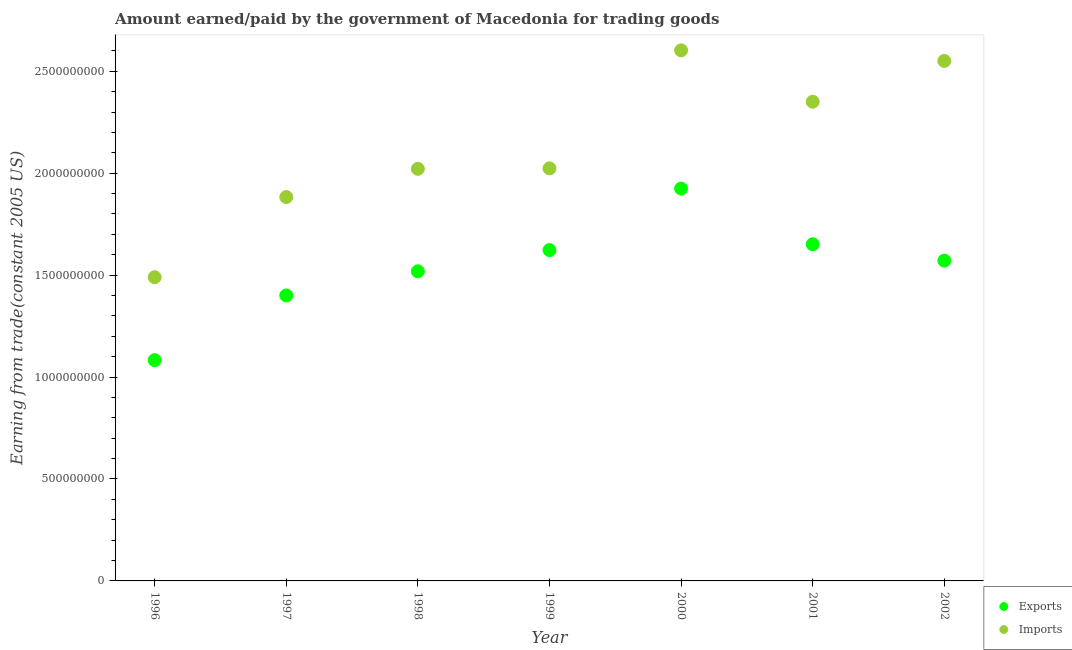How many different coloured dotlines are there?
Offer a very short reply. 2. What is the amount paid for imports in 2001?
Provide a succinct answer. 2.35e+09. Across all years, what is the maximum amount paid for imports?
Your response must be concise. 2.60e+09. Across all years, what is the minimum amount earned from exports?
Your answer should be very brief. 1.08e+09. In which year was the amount paid for imports minimum?
Give a very brief answer. 1996. What is the total amount earned from exports in the graph?
Give a very brief answer. 1.08e+1. What is the difference between the amount paid for imports in 1997 and that in 1999?
Provide a succinct answer. -1.41e+08. What is the difference between the amount earned from exports in 2001 and the amount paid for imports in 1996?
Offer a terse response. 1.62e+08. What is the average amount earned from exports per year?
Provide a short and direct response. 1.54e+09. In the year 2002, what is the difference between the amount earned from exports and amount paid for imports?
Make the answer very short. -9.80e+08. What is the ratio of the amount paid for imports in 1999 to that in 2000?
Give a very brief answer. 0.78. Is the difference between the amount paid for imports in 2000 and 2001 greater than the difference between the amount earned from exports in 2000 and 2001?
Your answer should be very brief. No. What is the difference between the highest and the second highest amount earned from exports?
Your answer should be compact. 2.73e+08. What is the difference between the highest and the lowest amount earned from exports?
Your answer should be very brief. 8.42e+08. Does the amount paid for imports monotonically increase over the years?
Provide a succinct answer. No. How many years are there in the graph?
Ensure brevity in your answer.  7. Does the graph contain any zero values?
Offer a very short reply. No. Does the graph contain grids?
Your response must be concise. No. How many legend labels are there?
Make the answer very short. 2. What is the title of the graph?
Your response must be concise. Amount earned/paid by the government of Macedonia for trading goods. What is the label or title of the Y-axis?
Give a very brief answer. Earning from trade(constant 2005 US). What is the Earning from trade(constant 2005 US) of Exports in 1996?
Offer a very short reply. 1.08e+09. What is the Earning from trade(constant 2005 US) in Imports in 1996?
Your answer should be compact. 1.49e+09. What is the Earning from trade(constant 2005 US) of Exports in 1997?
Offer a terse response. 1.40e+09. What is the Earning from trade(constant 2005 US) of Imports in 1997?
Keep it short and to the point. 1.88e+09. What is the Earning from trade(constant 2005 US) in Exports in 1998?
Your response must be concise. 1.52e+09. What is the Earning from trade(constant 2005 US) in Imports in 1998?
Give a very brief answer. 2.02e+09. What is the Earning from trade(constant 2005 US) of Exports in 1999?
Provide a short and direct response. 1.62e+09. What is the Earning from trade(constant 2005 US) of Imports in 1999?
Offer a terse response. 2.02e+09. What is the Earning from trade(constant 2005 US) in Exports in 2000?
Your answer should be compact. 1.92e+09. What is the Earning from trade(constant 2005 US) of Imports in 2000?
Make the answer very short. 2.60e+09. What is the Earning from trade(constant 2005 US) of Exports in 2001?
Make the answer very short. 1.65e+09. What is the Earning from trade(constant 2005 US) of Imports in 2001?
Keep it short and to the point. 2.35e+09. What is the Earning from trade(constant 2005 US) of Exports in 2002?
Ensure brevity in your answer.  1.57e+09. What is the Earning from trade(constant 2005 US) in Imports in 2002?
Make the answer very short. 2.55e+09. Across all years, what is the maximum Earning from trade(constant 2005 US) in Exports?
Your answer should be compact. 1.92e+09. Across all years, what is the maximum Earning from trade(constant 2005 US) in Imports?
Make the answer very short. 2.60e+09. Across all years, what is the minimum Earning from trade(constant 2005 US) of Exports?
Your answer should be compact. 1.08e+09. Across all years, what is the minimum Earning from trade(constant 2005 US) in Imports?
Provide a succinct answer. 1.49e+09. What is the total Earning from trade(constant 2005 US) of Exports in the graph?
Give a very brief answer. 1.08e+1. What is the total Earning from trade(constant 2005 US) of Imports in the graph?
Keep it short and to the point. 1.49e+1. What is the difference between the Earning from trade(constant 2005 US) of Exports in 1996 and that in 1997?
Your response must be concise. -3.17e+08. What is the difference between the Earning from trade(constant 2005 US) in Imports in 1996 and that in 1997?
Keep it short and to the point. -3.93e+08. What is the difference between the Earning from trade(constant 2005 US) of Exports in 1996 and that in 1998?
Give a very brief answer. -4.36e+08. What is the difference between the Earning from trade(constant 2005 US) of Imports in 1996 and that in 1998?
Provide a succinct answer. -5.32e+08. What is the difference between the Earning from trade(constant 2005 US) of Exports in 1996 and that in 1999?
Your answer should be compact. -5.40e+08. What is the difference between the Earning from trade(constant 2005 US) of Imports in 1996 and that in 1999?
Ensure brevity in your answer.  -5.34e+08. What is the difference between the Earning from trade(constant 2005 US) in Exports in 1996 and that in 2000?
Give a very brief answer. -8.42e+08. What is the difference between the Earning from trade(constant 2005 US) of Imports in 1996 and that in 2000?
Make the answer very short. -1.11e+09. What is the difference between the Earning from trade(constant 2005 US) of Exports in 1996 and that in 2001?
Ensure brevity in your answer.  -5.68e+08. What is the difference between the Earning from trade(constant 2005 US) of Imports in 1996 and that in 2001?
Keep it short and to the point. -8.61e+08. What is the difference between the Earning from trade(constant 2005 US) in Exports in 1996 and that in 2002?
Your answer should be compact. -4.88e+08. What is the difference between the Earning from trade(constant 2005 US) in Imports in 1996 and that in 2002?
Give a very brief answer. -1.06e+09. What is the difference between the Earning from trade(constant 2005 US) in Exports in 1997 and that in 1998?
Your answer should be compact. -1.18e+08. What is the difference between the Earning from trade(constant 2005 US) in Imports in 1997 and that in 1998?
Your answer should be compact. -1.38e+08. What is the difference between the Earning from trade(constant 2005 US) of Exports in 1997 and that in 1999?
Make the answer very short. -2.22e+08. What is the difference between the Earning from trade(constant 2005 US) of Imports in 1997 and that in 1999?
Make the answer very short. -1.41e+08. What is the difference between the Earning from trade(constant 2005 US) in Exports in 1997 and that in 2000?
Keep it short and to the point. -5.24e+08. What is the difference between the Earning from trade(constant 2005 US) of Imports in 1997 and that in 2000?
Your answer should be compact. -7.20e+08. What is the difference between the Earning from trade(constant 2005 US) of Exports in 1997 and that in 2001?
Give a very brief answer. -2.51e+08. What is the difference between the Earning from trade(constant 2005 US) in Imports in 1997 and that in 2001?
Your response must be concise. -4.67e+08. What is the difference between the Earning from trade(constant 2005 US) of Exports in 1997 and that in 2002?
Your answer should be very brief. -1.71e+08. What is the difference between the Earning from trade(constant 2005 US) in Imports in 1997 and that in 2002?
Provide a succinct answer. -6.68e+08. What is the difference between the Earning from trade(constant 2005 US) in Exports in 1998 and that in 1999?
Give a very brief answer. -1.04e+08. What is the difference between the Earning from trade(constant 2005 US) in Imports in 1998 and that in 1999?
Provide a short and direct response. -2.29e+06. What is the difference between the Earning from trade(constant 2005 US) of Exports in 1998 and that in 2000?
Make the answer very short. -4.06e+08. What is the difference between the Earning from trade(constant 2005 US) of Imports in 1998 and that in 2000?
Offer a terse response. -5.81e+08. What is the difference between the Earning from trade(constant 2005 US) in Exports in 1998 and that in 2001?
Keep it short and to the point. -1.33e+08. What is the difference between the Earning from trade(constant 2005 US) of Imports in 1998 and that in 2001?
Your answer should be very brief. -3.29e+08. What is the difference between the Earning from trade(constant 2005 US) in Exports in 1998 and that in 2002?
Offer a very short reply. -5.25e+07. What is the difference between the Earning from trade(constant 2005 US) of Imports in 1998 and that in 2002?
Provide a succinct answer. -5.29e+08. What is the difference between the Earning from trade(constant 2005 US) of Exports in 1999 and that in 2000?
Your answer should be very brief. -3.02e+08. What is the difference between the Earning from trade(constant 2005 US) of Imports in 1999 and that in 2000?
Give a very brief answer. -5.79e+08. What is the difference between the Earning from trade(constant 2005 US) of Exports in 1999 and that in 2001?
Ensure brevity in your answer.  -2.87e+07. What is the difference between the Earning from trade(constant 2005 US) of Imports in 1999 and that in 2001?
Make the answer very short. -3.27e+08. What is the difference between the Earning from trade(constant 2005 US) in Exports in 1999 and that in 2002?
Provide a succinct answer. 5.16e+07. What is the difference between the Earning from trade(constant 2005 US) in Imports in 1999 and that in 2002?
Make the answer very short. -5.27e+08. What is the difference between the Earning from trade(constant 2005 US) in Exports in 2000 and that in 2001?
Give a very brief answer. 2.73e+08. What is the difference between the Earning from trade(constant 2005 US) in Imports in 2000 and that in 2001?
Give a very brief answer. 2.52e+08. What is the difference between the Earning from trade(constant 2005 US) in Exports in 2000 and that in 2002?
Keep it short and to the point. 3.53e+08. What is the difference between the Earning from trade(constant 2005 US) of Imports in 2000 and that in 2002?
Your answer should be very brief. 5.18e+07. What is the difference between the Earning from trade(constant 2005 US) in Exports in 2001 and that in 2002?
Ensure brevity in your answer.  8.03e+07. What is the difference between the Earning from trade(constant 2005 US) of Imports in 2001 and that in 2002?
Provide a succinct answer. -2.00e+08. What is the difference between the Earning from trade(constant 2005 US) in Exports in 1996 and the Earning from trade(constant 2005 US) in Imports in 1997?
Make the answer very short. -8.00e+08. What is the difference between the Earning from trade(constant 2005 US) in Exports in 1996 and the Earning from trade(constant 2005 US) in Imports in 1998?
Ensure brevity in your answer.  -9.38e+08. What is the difference between the Earning from trade(constant 2005 US) of Exports in 1996 and the Earning from trade(constant 2005 US) of Imports in 1999?
Provide a short and direct response. -9.41e+08. What is the difference between the Earning from trade(constant 2005 US) in Exports in 1996 and the Earning from trade(constant 2005 US) in Imports in 2000?
Your answer should be very brief. -1.52e+09. What is the difference between the Earning from trade(constant 2005 US) of Exports in 1996 and the Earning from trade(constant 2005 US) of Imports in 2001?
Offer a terse response. -1.27e+09. What is the difference between the Earning from trade(constant 2005 US) of Exports in 1996 and the Earning from trade(constant 2005 US) of Imports in 2002?
Keep it short and to the point. -1.47e+09. What is the difference between the Earning from trade(constant 2005 US) in Exports in 1997 and the Earning from trade(constant 2005 US) in Imports in 1998?
Your response must be concise. -6.21e+08. What is the difference between the Earning from trade(constant 2005 US) in Exports in 1997 and the Earning from trade(constant 2005 US) in Imports in 1999?
Give a very brief answer. -6.23e+08. What is the difference between the Earning from trade(constant 2005 US) in Exports in 1997 and the Earning from trade(constant 2005 US) in Imports in 2000?
Offer a very short reply. -1.20e+09. What is the difference between the Earning from trade(constant 2005 US) of Exports in 1997 and the Earning from trade(constant 2005 US) of Imports in 2001?
Make the answer very short. -9.50e+08. What is the difference between the Earning from trade(constant 2005 US) in Exports in 1997 and the Earning from trade(constant 2005 US) in Imports in 2002?
Provide a succinct answer. -1.15e+09. What is the difference between the Earning from trade(constant 2005 US) in Exports in 1998 and the Earning from trade(constant 2005 US) in Imports in 1999?
Your answer should be very brief. -5.05e+08. What is the difference between the Earning from trade(constant 2005 US) of Exports in 1998 and the Earning from trade(constant 2005 US) of Imports in 2000?
Offer a very short reply. -1.08e+09. What is the difference between the Earning from trade(constant 2005 US) of Exports in 1998 and the Earning from trade(constant 2005 US) of Imports in 2001?
Your response must be concise. -8.32e+08. What is the difference between the Earning from trade(constant 2005 US) in Exports in 1998 and the Earning from trade(constant 2005 US) in Imports in 2002?
Keep it short and to the point. -1.03e+09. What is the difference between the Earning from trade(constant 2005 US) in Exports in 1999 and the Earning from trade(constant 2005 US) in Imports in 2000?
Provide a short and direct response. -9.80e+08. What is the difference between the Earning from trade(constant 2005 US) in Exports in 1999 and the Earning from trade(constant 2005 US) in Imports in 2001?
Provide a succinct answer. -7.28e+08. What is the difference between the Earning from trade(constant 2005 US) of Exports in 1999 and the Earning from trade(constant 2005 US) of Imports in 2002?
Your answer should be very brief. -9.28e+08. What is the difference between the Earning from trade(constant 2005 US) of Exports in 2000 and the Earning from trade(constant 2005 US) of Imports in 2001?
Make the answer very short. -4.26e+08. What is the difference between the Earning from trade(constant 2005 US) of Exports in 2000 and the Earning from trade(constant 2005 US) of Imports in 2002?
Keep it short and to the point. -6.26e+08. What is the difference between the Earning from trade(constant 2005 US) of Exports in 2001 and the Earning from trade(constant 2005 US) of Imports in 2002?
Ensure brevity in your answer.  -8.99e+08. What is the average Earning from trade(constant 2005 US) of Exports per year?
Provide a short and direct response. 1.54e+09. What is the average Earning from trade(constant 2005 US) in Imports per year?
Offer a very short reply. 2.13e+09. In the year 1996, what is the difference between the Earning from trade(constant 2005 US) in Exports and Earning from trade(constant 2005 US) in Imports?
Offer a terse response. -4.07e+08. In the year 1997, what is the difference between the Earning from trade(constant 2005 US) in Exports and Earning from trade(constant 2005 US) in Imports?
Your answer should be very brief. -4.83e+08. In the year 1998, what is the difference between the Earning from trade(constant 2005 US) of Exports and Earning from trade(constant 2005 US) of Imports?
Your answer should be compact. -5.03e+08. In the year 1999, what is the difference between the Earning from trade(constant 2005 US) in Exports and Earning from trade(constant 2005 US) in Imports?
Ensure brevity in your answer.  -4.01e+08. In the year 2000, what is the difference between the Earning from trade(constant 2005 US) of Exports and Earning from trade(constant 2005 US) of Imports?
Provide a succinct answer. -6.78e+08. In the year 2001, what is the difference between the Earning from trade(constant 2005 US) in Exports and Earning from trade(constant 2005 US) in Imports?
Your answer should be compact. -6.99e+08. In the year 2002, what is the difference between the Earning from trade(constant 2005 US) of Exports and Earning from trade(constant 2005 US) of Imports?
Offer a terse response. -9.80e+08. What is the ratio of the Earning from trade(constant 2005 US) of Exports in 1996 to that in 1997?
Your response must be concise. 0.77. What is the ratio of the Earning from trade(constant 2005 US) in Imports in 1996 to that in 1997?
Offer a very short reply. 0.79. What is the ratio of the Earning from trade(constant 2005 US) of Exports in 1996 to that in 1998?
Your response must be concise. 0.71. What is the ratio of the Earning from trade(constant 2005 US) of Imports in 1996 to that in 1998?
Make the answer very short. 0.74. What is the ratio of the Earning from trade(constant 2005 US) of Exports in 1996 to that in 1999?
Give a very brief answer. 0.67. What is the ratio of the Earning from trade(constant 2005 US) of Imports in 1996 to that in 1999?
Ensure brevity in your answer.  0.74. What is the ratio of the Earning from trade(constant 2005 US) in Exports in 1996 to that in 2000?
Keep it short and to the point. 0.56. What is the ratio of the Earning from trade(constant 2005 US) of Imports in 1996 to that in 2000?
Keep it short and to the point. 0.57. What is the ratio of the Earning from trade(constant 2005 US) of Exports in 1996 to that in 2001?
Keep it short and to the point. 0.66. What is the ratio of the Earning from trade(constant 2005 US) in Imports in 1996 to that in 2001?
Your answer should be very brief. 0.63. What is the ratio of the Earning from trade(constant 2005 US) of Exports in 1996 to that in 2002?
Your answer should be very brief. 0.69. What is the ratio of the Earning from trade(constant 2005 US) of Imports in 1996 to that in 2002?
Give a very brief answer. 0.58. What is the ratio of the Earning from trade(constant 2005 US) of Exports in 1997 to that in 1998?
Offer a very short reply. 0.92. What is the ratio of the Earning from trade(constant 2005 US) in Imports in 1997 to that in 1998?
Offer a terse response. 0.93. What is the ratio of the Earning from trade(constant 2005 US) in Exports in 1997 to that in 1999?
Your answer should be compact. 0.86. What is the ratio of the Earning from trade(constant 2005 US) of Imports in 1997 to that in 1999?
Offer a very short reply. 0.93. What is the ratio of the Earning from trade(constant 2005 US) in Exports in 1997 to that in 2000?
Your response must be concise. 0.73. What is the ratio of the Earning from trade(constant 2005 US) of Imports in 1997 to that in 2000?
Offer a terse response. 0.72. What is the ratio of the Earning from trade(constant 2005 US) in Exports in 1997 to that in 2001?
Provide a succinct answer. 0.85. What is the ratio of the Earning from trade(constant 2005 US) in Imports in 1997 to that in 2001?
Your answer should be very brief. 0.8. What is the ratio of the Earning from trade(constant 2005 US) of Exports in 1997 to that in 2002?
Your answer should be very brief. 0.89. What is the ratio of the Earning from trade(constant 2005 US) of Imports in 1997 to that in 2002?
Your answer should be compact. 0.74. What is the ratio of the Earning from trade(constant 2005 US) of Exports in 1998 to that in 1999?
Give a very brief answer. 0.94. What is the ratio of the Earning from trade(constant 2005 US) of Exports in 1998 to that in 2000?
Your response must be concise. 0.79. What is the ratio of the Earning from trade(constant 2005 US) in Imports in 1998 to that in 2000?
Your response must be concise. 0.78. What is the ratio of the Earning from trade(constant 2005 US) of Exports in 1998 to that in 2001?
Your answer should be very brief. 0.92. What is the ratio of the Earning from trade(constant 2005 US) in Imports in 1998 to that in 2001?
Your answer should be compact. 0.86. What is the ratio of the Earning from trade(constant 2005 US) in Exports in 1998 to that in 2002?
Give a very brief answer. 0.97. What is the ratio of the Earning from trade(constant 2005 US) in Imports in 1998 to that in 2002?
Provide a succinct answer. 0.79. What is the ratio of the Earning from trade(constant 2005 US) of Exports in 1999 to that in 2000?
Give a very brief answer. 0.84. What is the ratio of the Earning from trade(constant 2005 US) in Imports in 1999 to that in 2000?
Offer a very short reply. 0.78. What is the ratio of the Earning from trade(constant 2005 US) in Exports in 1999 to that in 2001?
Offer a very short reply. 0.98. What is the ratio of the Earning from trade(constant 2005 US) of Imports in 1999 to that in 2001?
Offer a very short reply. 0.86. What is the ratio of the Earning from trade(constant 2005 US) of Exports in 1999 to that in 2002?
Ensure brevity in your answer.  1.03. What is the ratio of the Earning from trade(constant 2005 US) in Imports in 1999 to that in 2002?
Your answer should be very brief. 0.79. What is the ratio of the Earning from trade(constant 2005 US) of Exports in 2000 to that in 2001?
Keep it short and to the point. 1.17. What is the ratio of the Earning from trade(constant 2005 US) in Imports in 2000 to that in 2001?
Your answer should be very brief. 1.11. What is the ratio of the Earning from trade(constant 2005 US) in Exports in 2000 to that in 2002?
Provide a succinct answer. 1.23. What is the ratio of the Earning from trade(constant 2005 US) in Imports in 2000 to that in 2002?
Offer a very short reply. 1.02. What is the ratio of the Earning from trade(constant 2005 US) of Exports in 2001 to that in 2002?
Your response must be concise. 1.05. What is the ratio of the Earning from trade(constant 2005 US) in Imports in 2001 to that in 2002?
Provide a short and direct response. 0.92. What is the difference between the highest and the second highest Earning from trade(constant 2005 US) of Exports?
Offer a very short reply. 2.73e+08. What is the difference between the highest and the second highest Earning from trade(constant 2005 US) in Imports?
Make the answer very short. 5.18e+07. What is the difference between the highest and the lowest Earning from trade(constant 2005 US) in Exports?
Provide a short and direct response. 8.42e+08. What is the difference between the highest and the lowest Earning from trade(constant 2005 US) in Imports?
Give a very brief answer. 1.11e+09. 